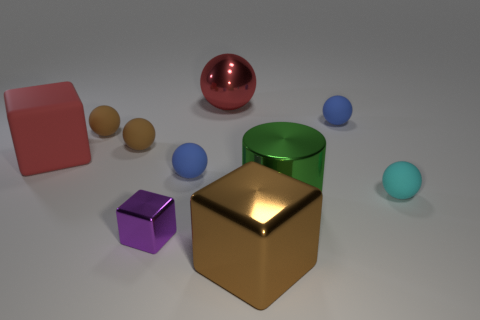There is a small metal thing that is the same shape as the big rubber thing; what is its color?
Provide a short and direct response. Purple. What number of big shiny things are the same color as the shiny cylinder?
Make the answer very short. 0. What color is the big cylinder that is in front of the small blue matte thing right of the brown object in front of the big green cylinder?
Your answer should be very brief. Green. Do the big brown cube and the cyan sphere have the same material?
Give a very brief answer. No. Do the tiny cyan object and the large red rubber thing have the same shape?
Offer a terse response. No. Are there an equal number of large brown objects that are behind the red cube and tiny brown balls behind the purple metallic thing?
Your response must be concise. No. The large block that is the same material as the large cylinder is what color?
Offer a terse response. Brown. How many red spheres are made of the same material as the purple thing?
Make the answer very short. 1. There is a small object that is in front of the big green shiny thing; does it have the same color as the large cylinder?
Give a very brief answer. No. What number of other tiny cyan things have the same shape as the cyan object?
Provide a succinct answer. 0. 